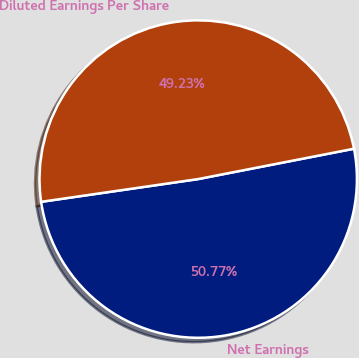Convert chart to OTSL. <chart><loc_0><loc_0><loc_500><loc_500><pie_chart><fcel>Net Earnings<fcel>Diluted Earnings Per Share<nl><fcel>50.77%<fcel>49.23%<nl></chart> 